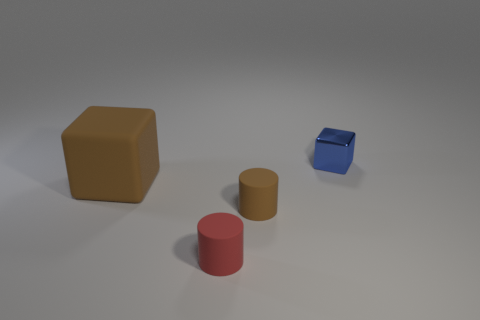Is there any other thing that is the same size as the brown matte cube?
Provide a succinct answer. No. Are there any things on the left side of the big object?
Offer a terse response. No. Are there any tiny red things that are in front of the cube in front of the cube that is to the right of the large rubber block?
Ensure brevity in your answer.  Yes. Does the brown thing on the left side of the tiny red cylinder have the same shape as the tiny metallic thing?
Make the answer very short. Yes. There is a tiny cylinder that is made of the same material as the small brown thing; what is its color?
Your response must be concise. Red. What number of cylinders are made of the same material as the big object?
Keep it short and to the point. 2. There is a cube left of the small matte cylinder in front of the cylinder behind the small red cylinder; what is its color?
Your answer should be compact. Brown. Do the brown cube and the brown cylinder have the same size?
Ensure brevity in your answer.  No. Is there any other thing that has the same shape as the big brown thing?
Ensure brevity in your answer.  Yes. What number of objects are tiny things that are behind the large brown thing or rubber objects?
Keep it short and to the point. 4. 